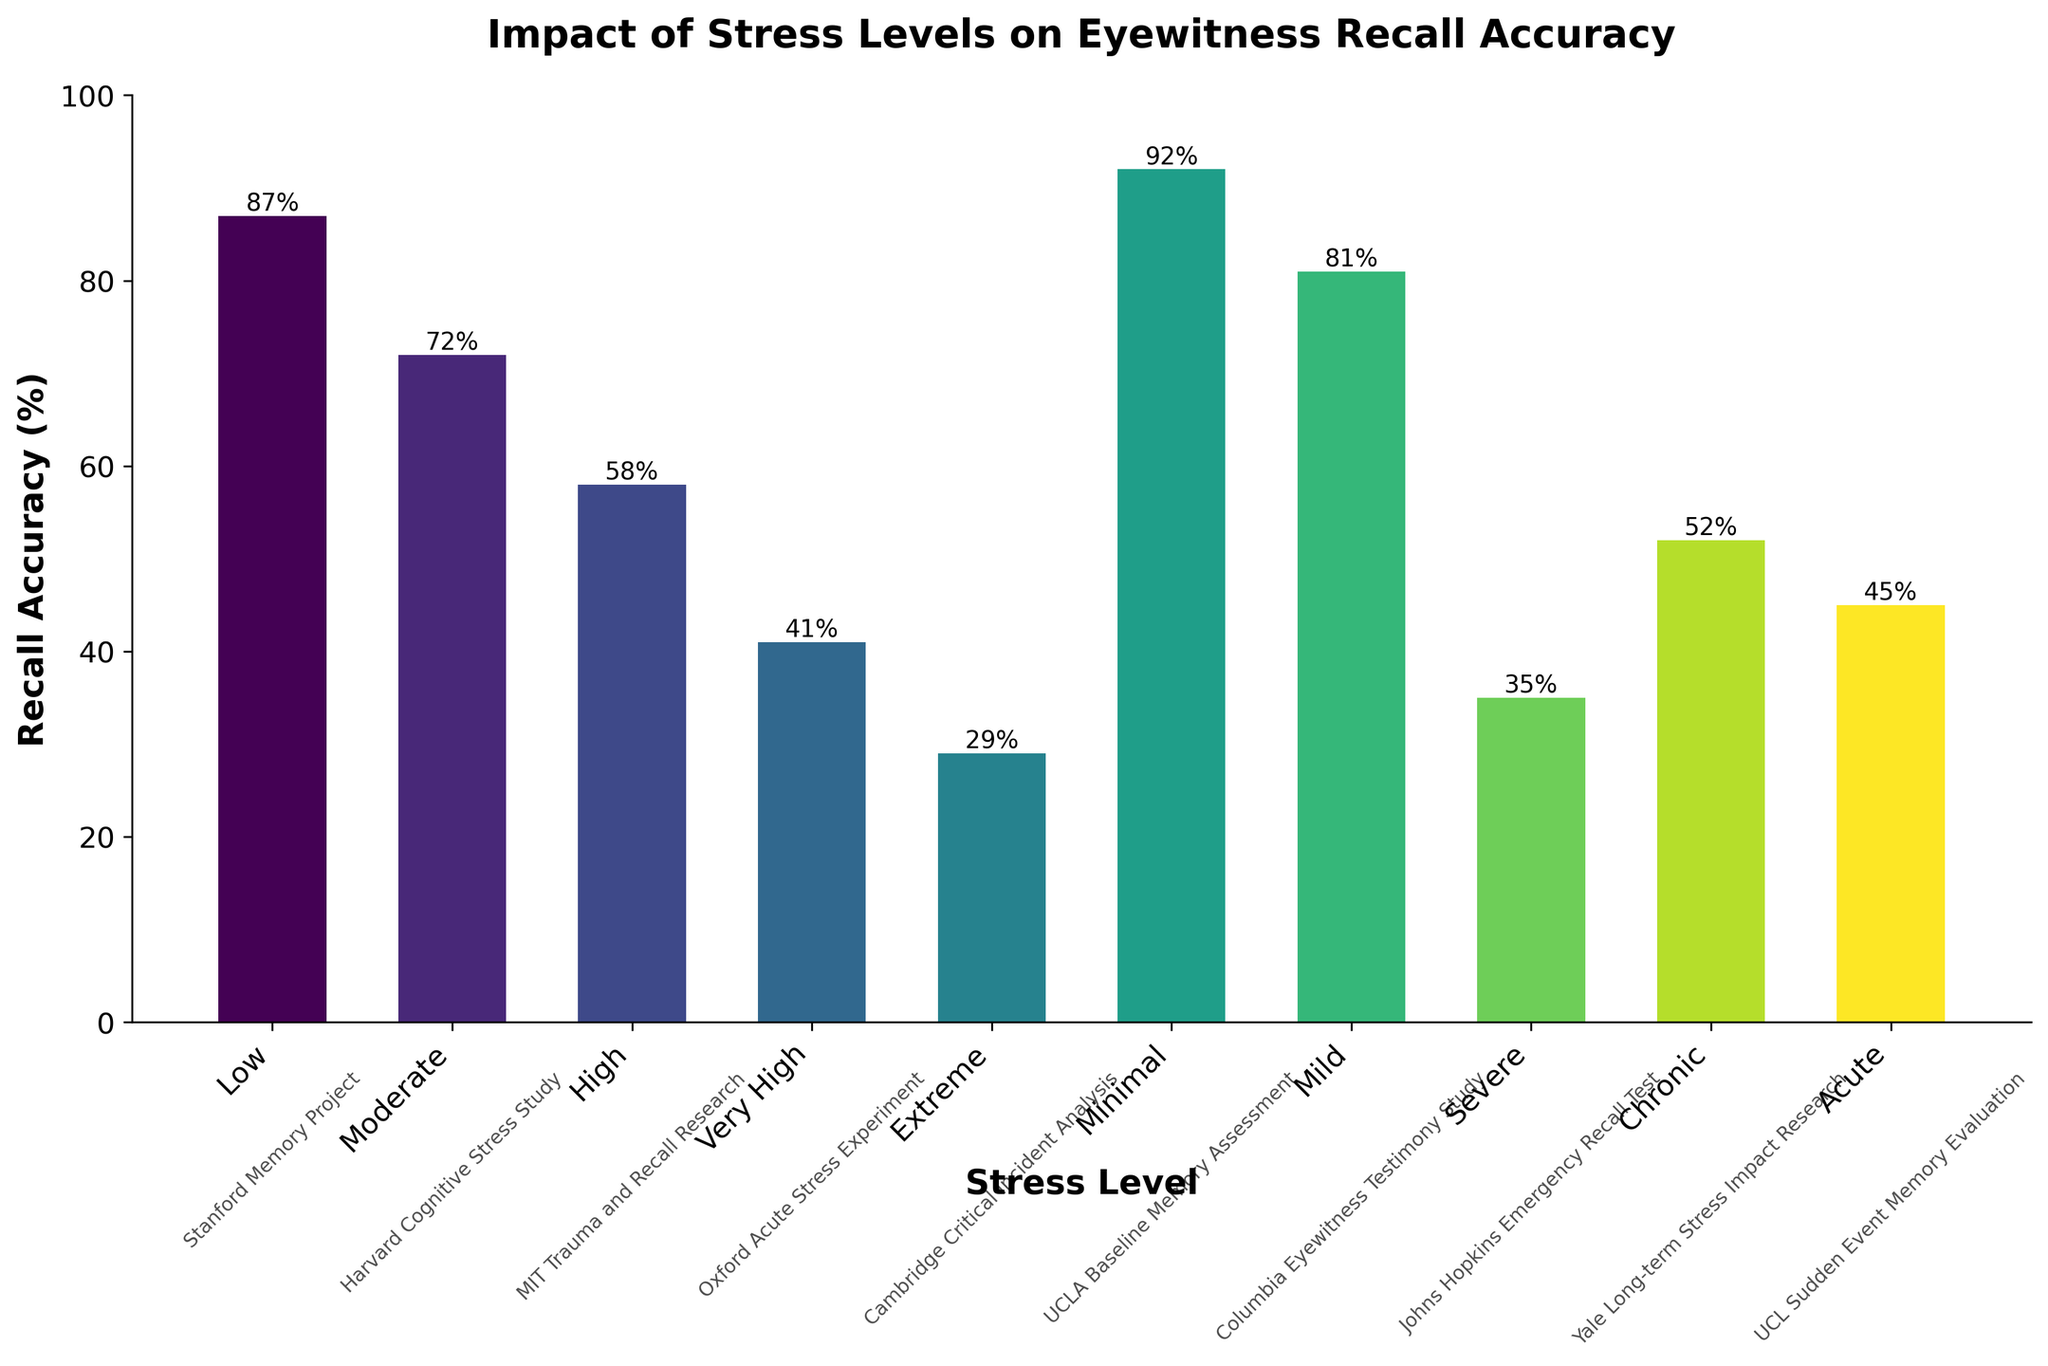What's the recall accuracy for the 'Moderate' stress level? Look at the bar labeled 'Moderate' on the x-axis and note the height of the bar, which represents the recall accuracy percentage.
Answer: 72% Which stress level has the highest recall accuracy? Identify the tallest bar in the chart and note its corresponding stress level label.
Answer: Minimal At which stress level does recall accuracy drop below 50% for the first time? Scan the chart from left to right and identify the first bar with a height representing less than 50% recall accuracy.
Answer: High What is the difference in recall accuracy between 'Low' and 'Extreme' stress levels? Find the heights of the bars labeled 'Low' and 'Extreme'. Subtract the recall accuracy for 'Extreme' from that of 'Low' (87% - 29%).
Answer: 58% Which study corresponds to the 'Severe' stress level? Look below the bar labeled 'Severe' to find the associated study name written underneath.
Answer: Johns Hopkins Emergency Recall Test How does the recall accuracy under 'Chronic' stress compare to 'Acute' stress? Compare the heights of the bars labeled 'Chronic' and 'Acute'. Determine which bar is taller or if they're the same.
Answer: Chronic is higher What is the average recall accuracy of stress levels 'Minimal', 'Mild', and 'Moderate'? Find the recall accuracy for 'Minimal' (92%), 'Mild' (81%), and 'Moderate' (72%). Calculate the average: (92 + 81 + 72) / 3.
Answer: 81.7% Is the recall accuracy for 'Very High' stress level greater than or equal to 'Acute' stress level? Compare the heights of the bars labeled 'Very High' and 'Acute'. Check if the height of 'Very High' is at least as high as 'Acute'.
Answer: No Which stress level has the third lowest recall accuracy? Order the bars by height and identify the third shortest bar, then note its corresponding stress level.
Answer: Acute What is the median recall accuracy of all the stress levels? List the recall accuracy percentages in ascending order: 29, 35, 41, 45, 52, 58, 72, 81, 87, 92. Find the middle value (median) in this list.
Answer: 55% 